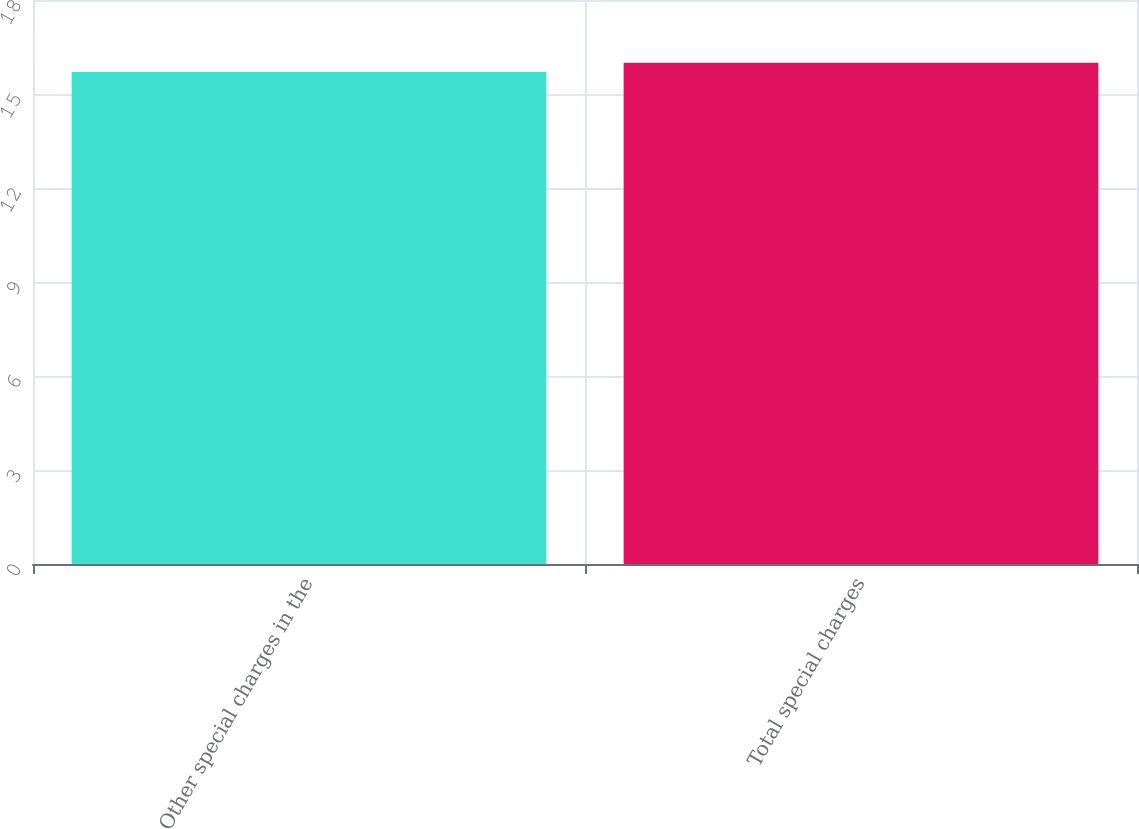Convert chart. <chart><loc_0><loc_0><loc_500><loc_500><bar_chart><fcel>Other special charges in the<fcel>Total special charges<nl><fcel>15.7<fcel>16<nl></chart> 